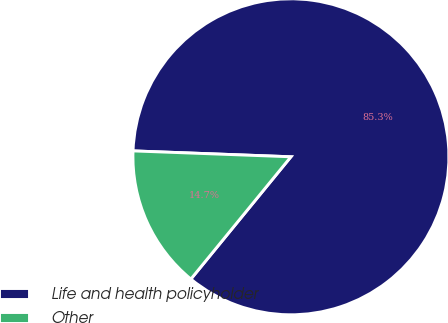Convert chart. <chart><loc_0><loc_0><loc_500><loc_500><pie_chart><fcel>Life and health policyholder<fcel>Other<nl><fcel>85.32%<fcel>14.68%<nl></chart> 